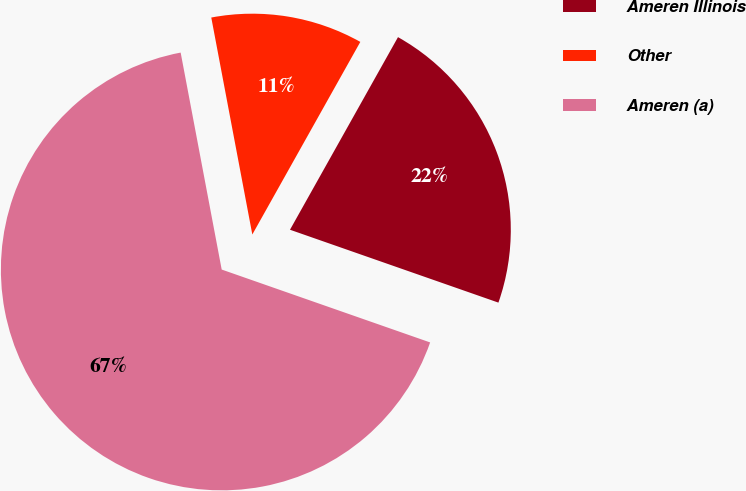Convert chart to OTSL. <chart><loc_0><loc_0><loc_500><loc_500><pie_chart><fcel>Ameren Illinois<fcel>Other<fcel>Ameren (a)<nl><fcel>22.22%<fcel>11.11%<fcel>66.67%<nl></chart> 